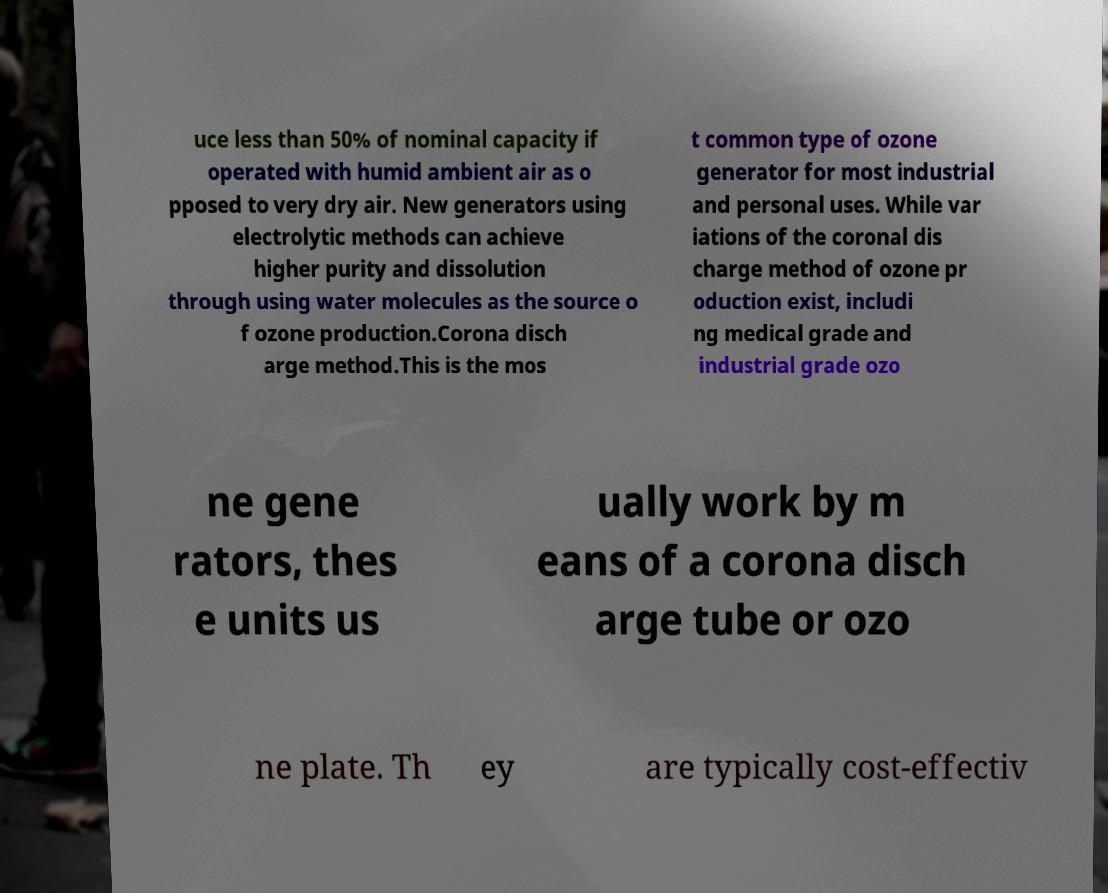Could you assist in decoding the text presented in this image and type it out clearly? uce less than 50% of nominal capacity if operated with humid ambient air as o pposed to very dry air. New generators using electrolytic methods can achieve higher purity and dissolution through using water molecules as the source o f ozone production.Corona disch arge method.This is the mos t common type of ozone generator for most industrial and personal uses. While var iations of the coronal dis charge method of ozone pr oduction exist, includi ng medical grade and industrial grade ozo ne gene rators, thes e units us ually work by m eans of a corona disch arge tube or ozo ne plate. Th ey are typically cost-effectiv 